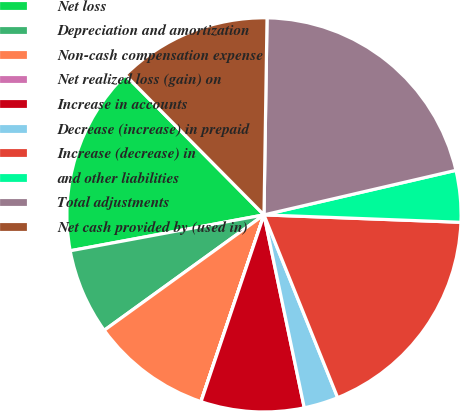Convert chart. <chart><loc_0><loc_0><loc_500><loc_500><pie_chart><fcel>Net loss<fcel>Depreciation and amortization<fcel>Non-cash compensation expense<fcel>Net realized loss (gain) on<fcel>Increase in accounts<fcel>Decrease (increase) in prepaid<fcel>Increase (decrease) in<fcel>and other liabilities<fcel>Total adjustments<fcel>Net cash provided by (used in)<nl><fcel>15.49%<fcel>7.04%<fcel>9.86%<fcel>0.01%<fcel>8.45%<fcel>2.82%<fcel>18.3%<fcel>4.23%<fcel>21.12%<fcel>12.67%<nl></chart> 